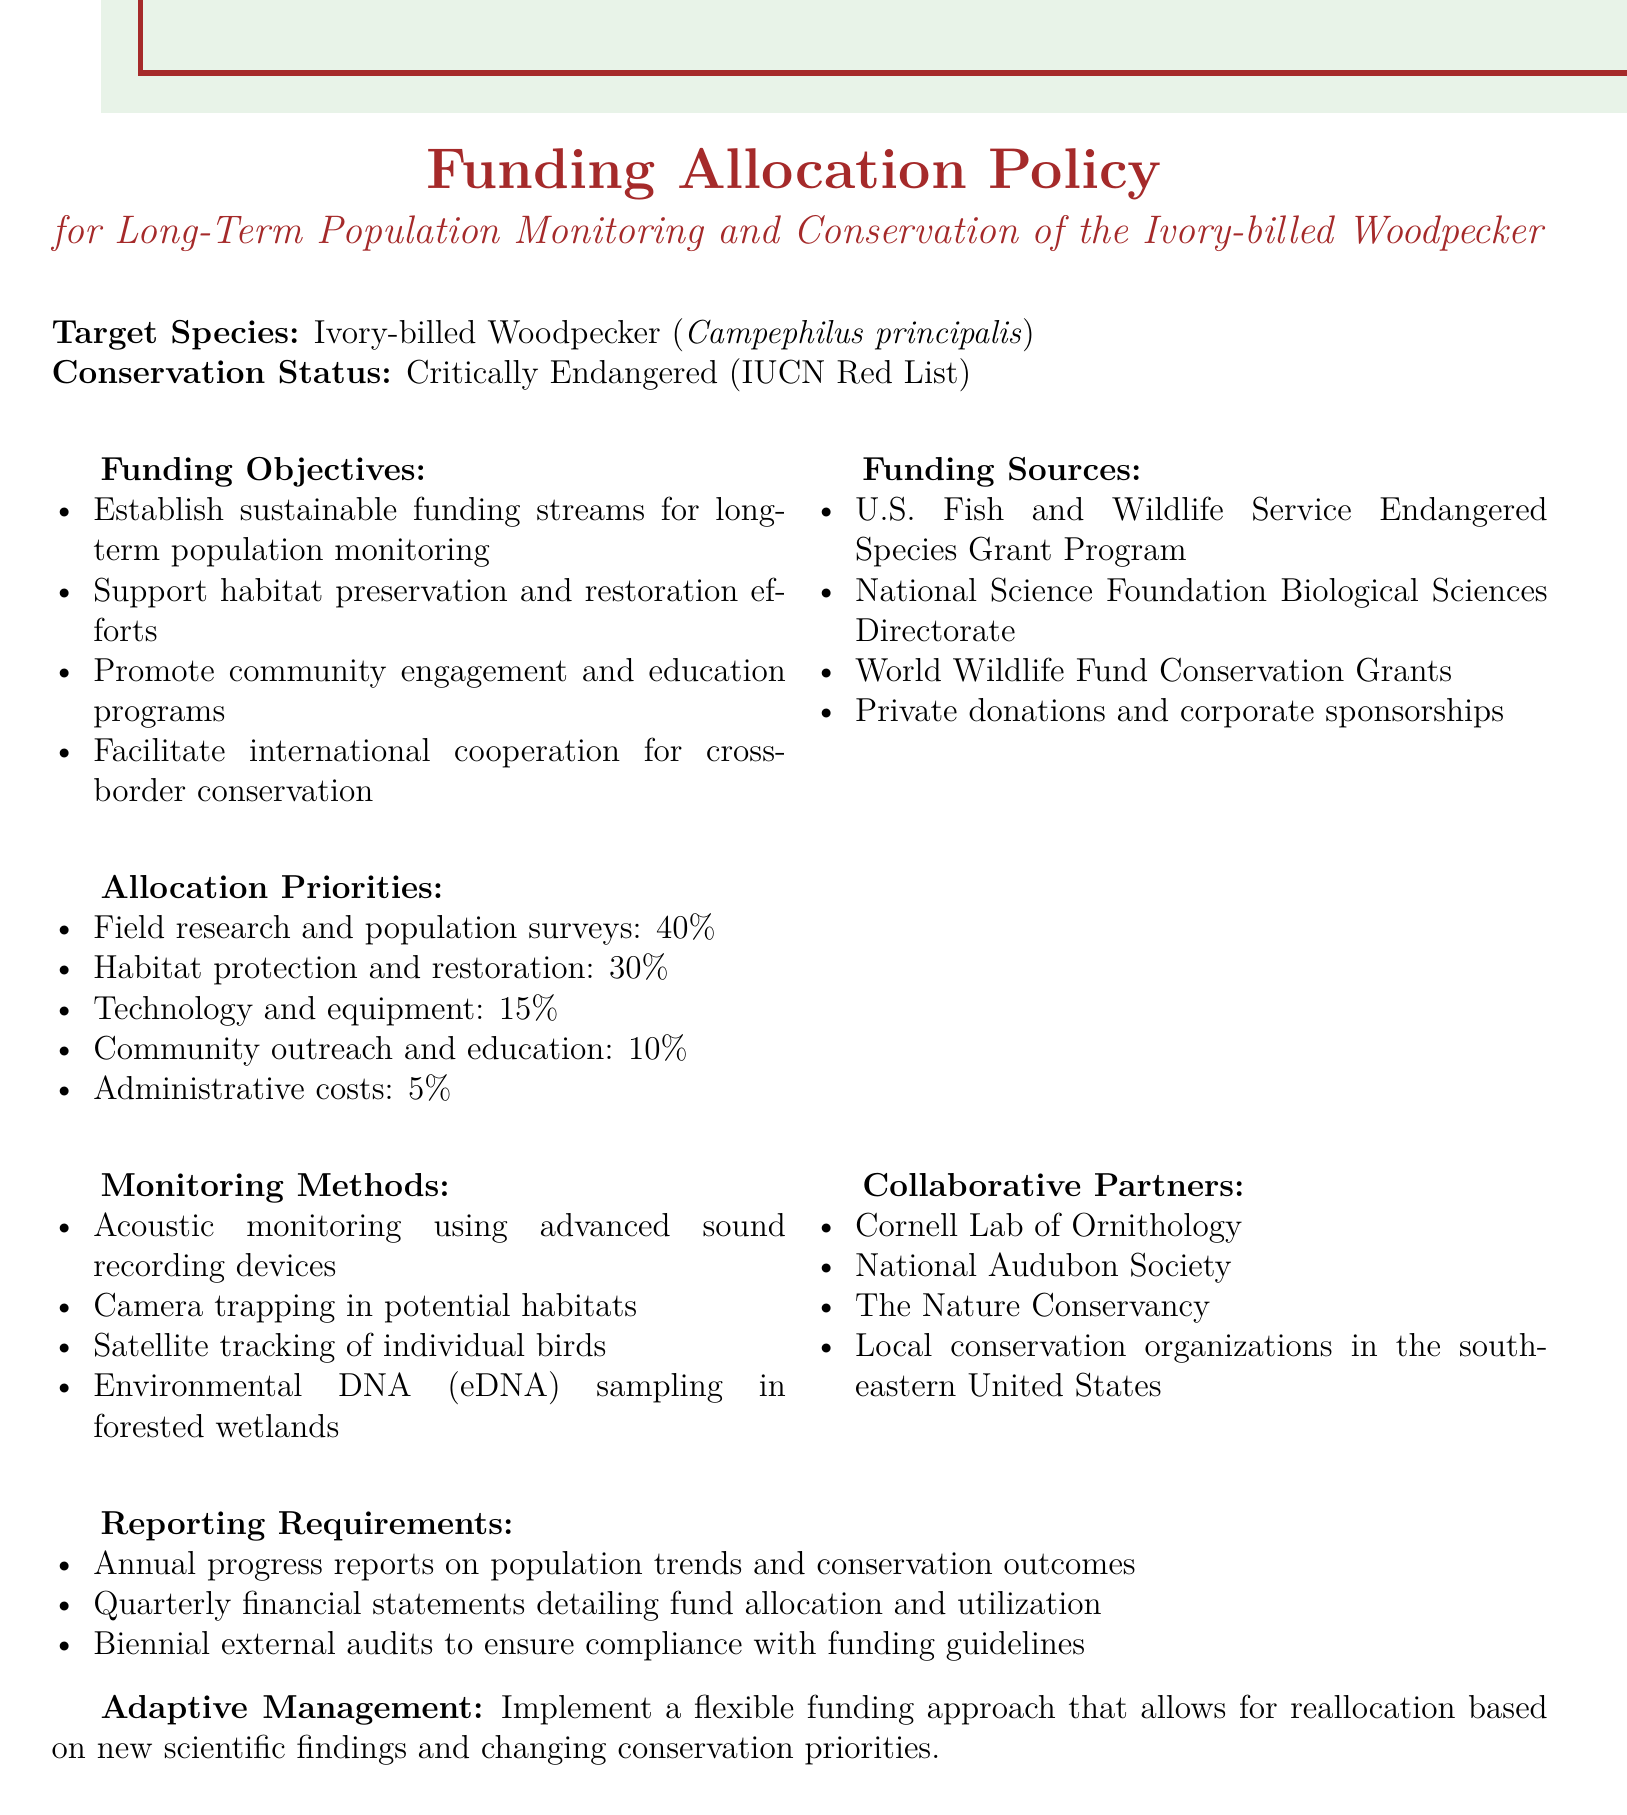What is the target species? The target species defined in the document is the Ivory-billed Woodpecker.
Answer: Ivory-billed Woodpecker What is the conservation status of the bird? The document states the conservation status of the Ivory-billed Woodpecker as Critically Endangered.
Answer: Critically Endangered What percentage of funds is allocated to field research and population surveys? The document outlines that 40% of the funding is allocated to field research and population surveys.
Answer: 40% Which organization is listed as a collaborative partner? The document lists several organizations, one of which is the Cornell Lab of Ornithology.
Answer: Cornell Lab of Ornithology What is one of the monitoring methods mentioned? The document mentions several methods, including acoustic monitoring using advanced sound recording devices.
Answer: Acoustic monitoring How often are financial statements required? The document specifies that quarterly financial statements detailing fund allocation and utilization are required.
Answer: Quarterly What is one objective of the funding? One of the funding objectives listed in the document is to support habitat preservation and restoration efforts.
Answer: Support habitat preservation and restoration efforts What is the allocation percentage for community outreach and education? The document states that 10% of the funding is allocated to community outreach and education.
Answer: 10% 